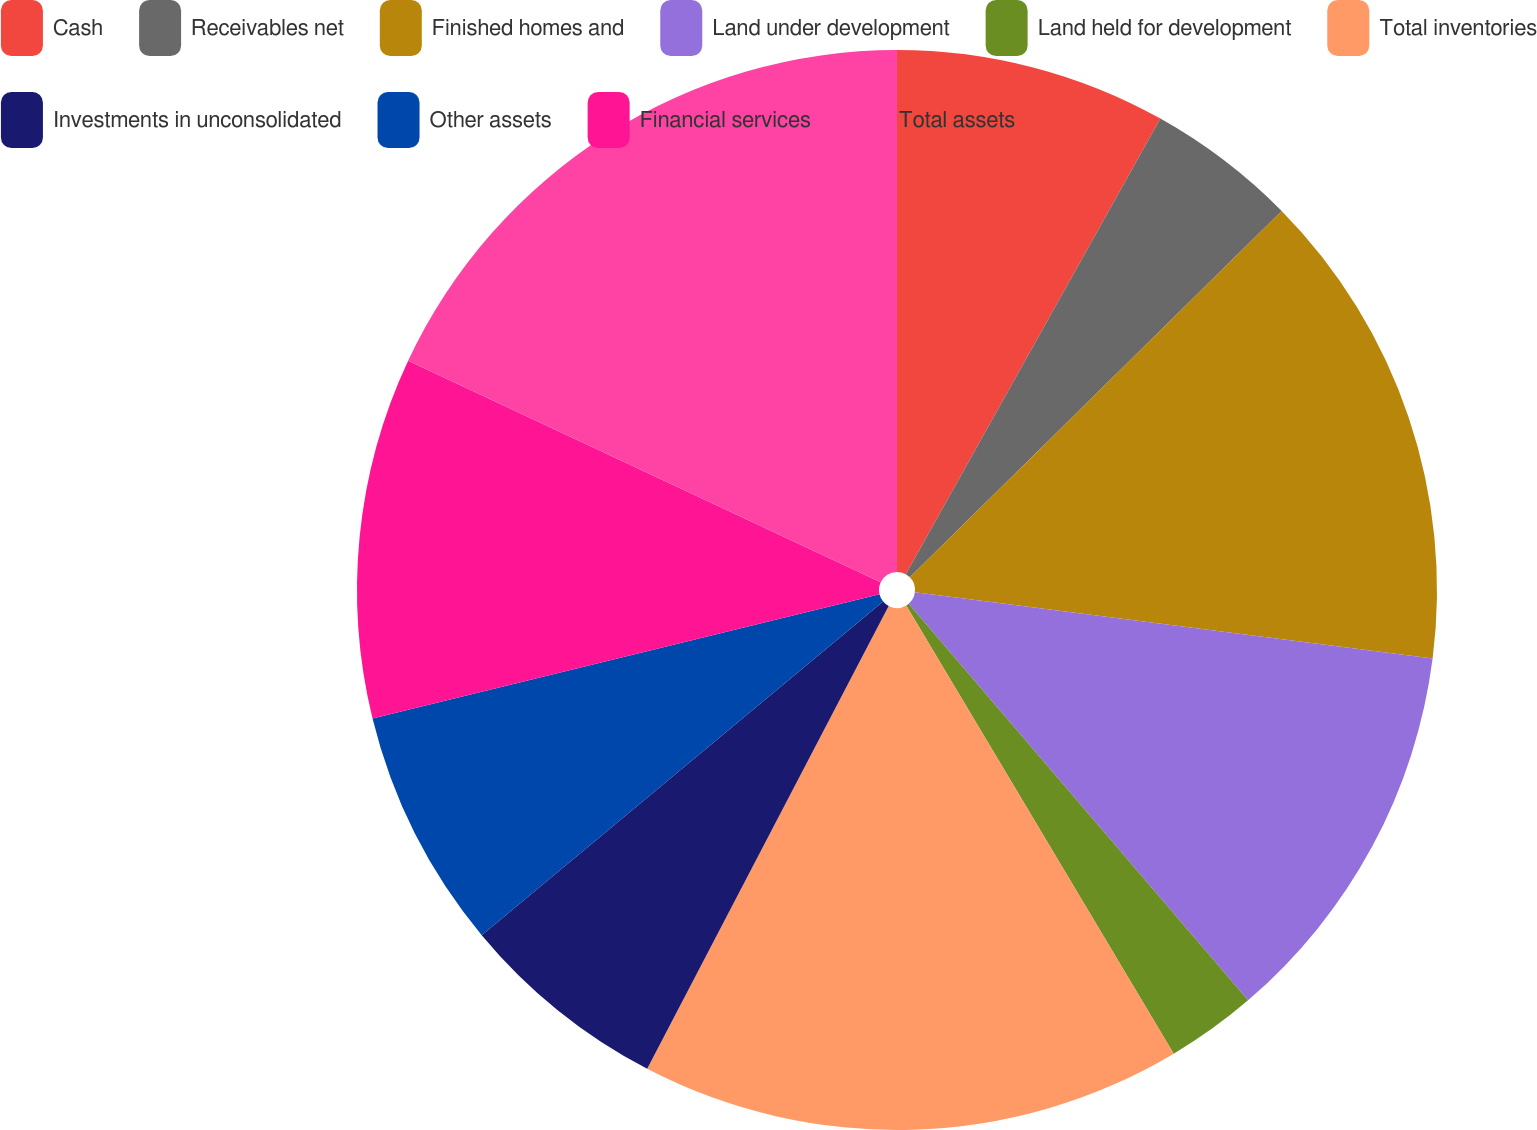Convert chart to OTSL. <chart><loc_0><loc_0><loc_500><loc_500><pie_chart><fcel>Cash<fcel>Receivables net<fcel>Finished homes and<fcel>Land under development<fcel>Land held for development<fcel>Total inventories<fcel>Investments in unconsolidated<fcel>Other assets<fcel>Financial services<fcel>Total assets<nl><fcel>8.11%<fcel>4.51%<fcel>14.41%<fcel>11.71%<fcel>2.7%<fcel>16.22%<fcel>6.31%<fcel>7.21%<fcel>10.81%<fcel>18.02%<nl></chart> 